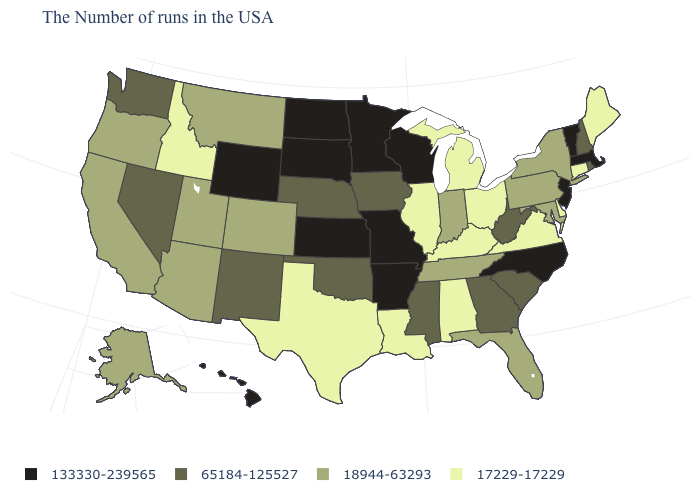Does the first symbol in the legend represent the smallest category?
Give a very brief answer. No. What is the highest value in states that border North Carolina?
Write a very short answer. 65184-125527. Name the states that have a value in the range 18944-63293?
Answer briefly. New York, Maryland, Pennsylvania, Florida, Indiana, Tennessee, Colorado, Utah, Montana, Arizona, California, Oregon, Alaska. What is the value of Connecticut?
Quick response, please. 17229-17229. What is the value of Florida?
Concise answer only. 18944-63293. Name the states that have a value in the range 17229-17229?
Concise answer only. Maine, Connecticut, Delaware, Virginia, Ohio, Michigan, Kentucky, Alabama, Illinois, Louisiana, Texas, Idaho. Does North Carolina have the same value as Massachusetts?
Concise answer only. Yes. What is the value of Alabama?
Quick response, please. 17229-17229. Does Connecticut have the highest value in the USA?
Keep it brief. No. What is the highest value in states that border Virginia?
Answer briefly. 133330-239565. Name the states that have a value in the range 65184-125527?
Be succinct. Rhode Island, New Hampshire, South Carolina, West Virginia, Georgia, Mississippi, Iowa, Nebraska, Oklahoma, New Mexico, Nevada, Washington. Does Kentucky have a lower value than Wisconsin?
Concise answer only. Yes. Among the states that border Colorado , which have the highest value?
Give a very brief answer. Kansas, Wyoming. Name the states that have a value in the range 133330-239565?
Write a very short answer. Massachusetts, Vermont, New Jersey, North Carolina, Wisconsin, Missouri, Arkansas, Minnesota, Kansas, South Dakota, North Dakota, Wyoming, Hawaii. Name the states that have a value in the range 133330-239565?
Short answer required. Massachusetts, Vermont, New Jersey, North Carolina, Wisconsin, Missouri, Arkansas, Minnesota, Kansas, South Dakota, North Dakota, Wyoming, Hawaii. 